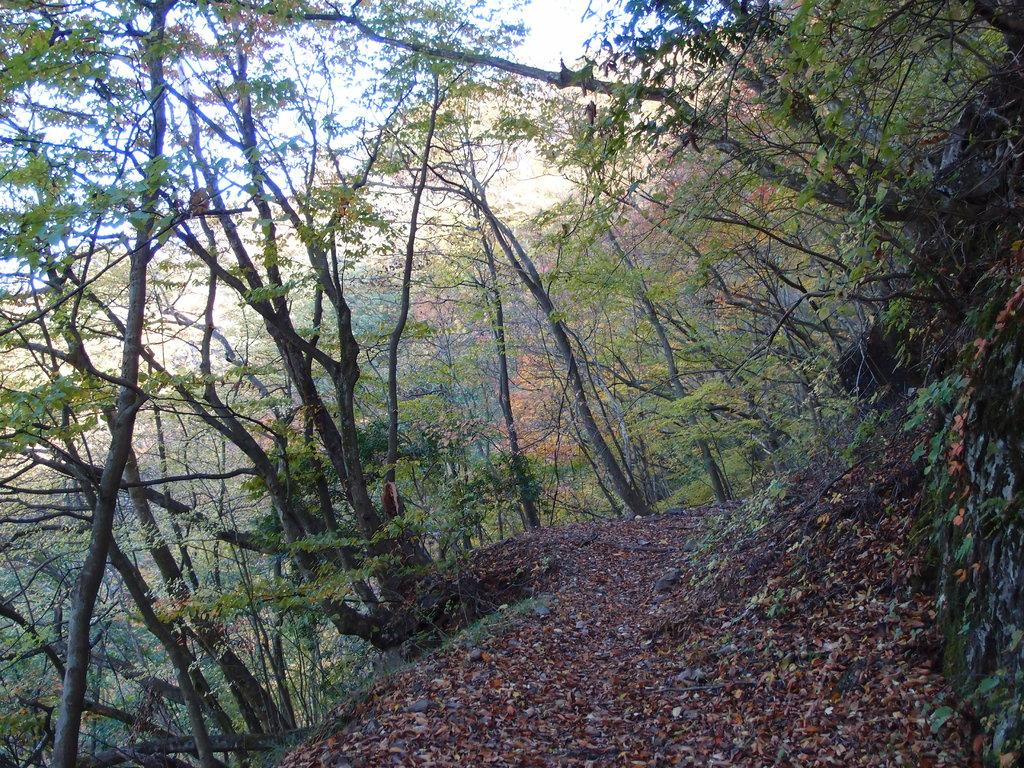What type of vegetation can be seen in the image? There are many trees, plants, and grass visible in the image. What is located at the bottom of the image? Leaves are visible at the bottom of the image. What can be seen in the background of the image? There is a mountain in the background of the image. What is visible at the top of the image? The sky is visible at the top of the image. Where is the playground located in the image? There is no playground present in the image. What type of kitty can be seen playing near the trees in the image? There is no kitty present in the image. 